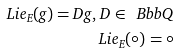<formula> <loc_0><loc_0><loc_500><loc_500>L i e _ { E } ( g ) = D g , \, D \in { \ B b b Q } \\ L i e _ { E } ( \circ ) = \circ</formula> 